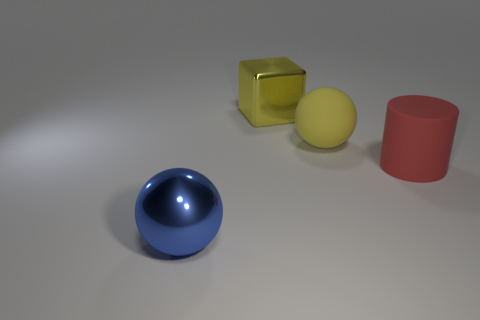Add 2 large matte things. How many objects exist? 6 Subtract all cylinders. How many objects are left? 3 Subtract all large red metal objects. Subtract all red rubber things. How many objects are left? 3 Add 1 large yellow objects. How many large yellow objects are left? 3 Add 3 yellow rubber things. How many yellow rubber things exist? 4 Subtract 0 purple cubes. How many objects are left? 4 